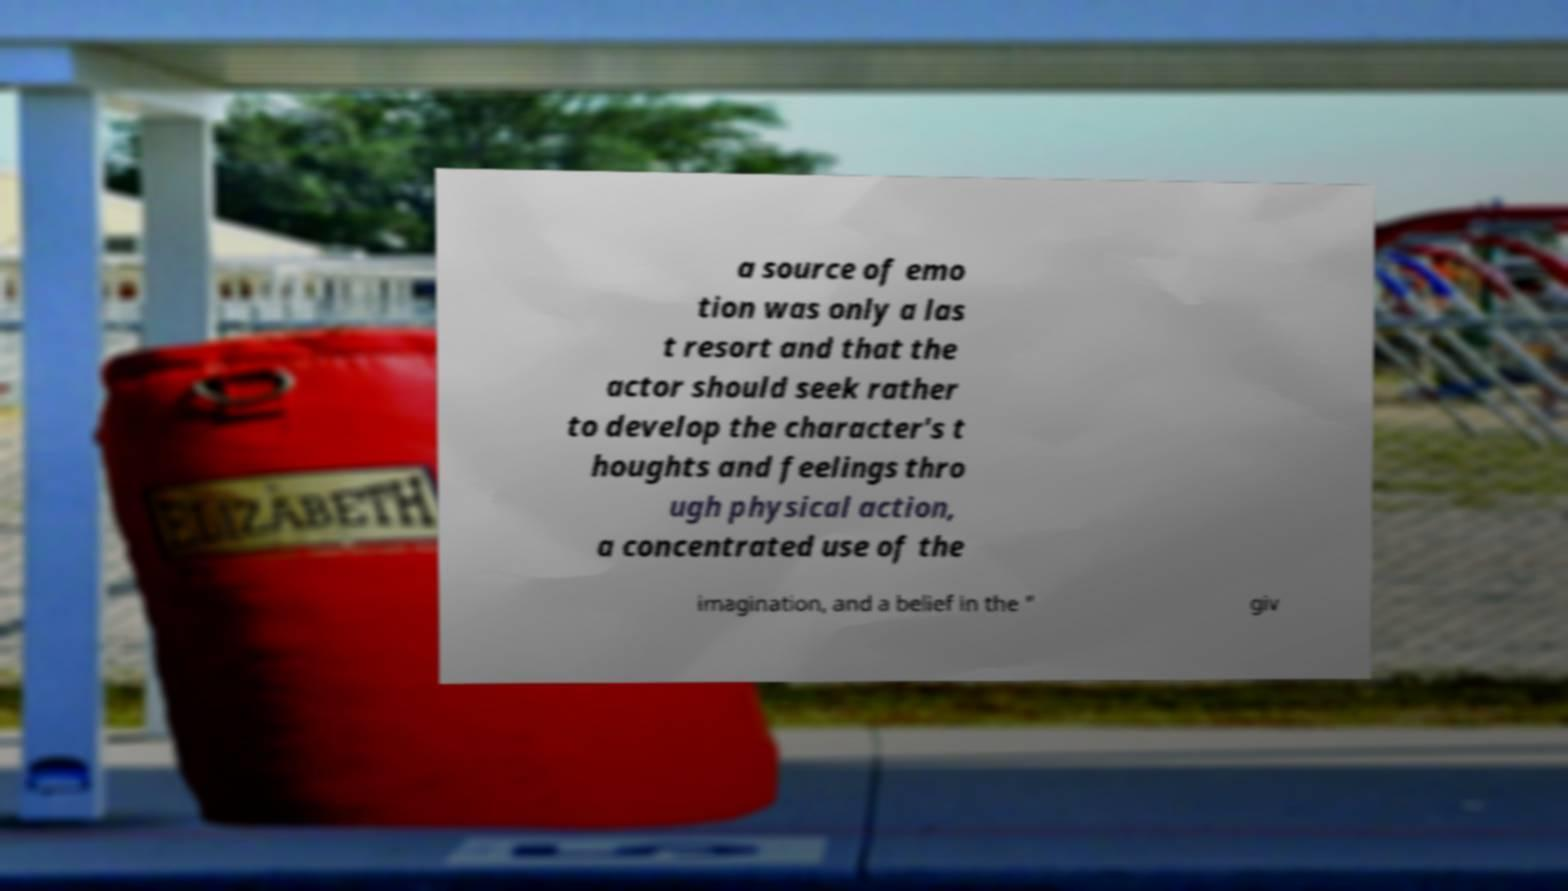Please identify and transcribe the text found in this image. a source of emo tion was only a las t resort and that the actor should seek rather to develop the character's t houghts and feelings thro ugh physical action, a concentrated use of the imagination, and a belief in the " giv 